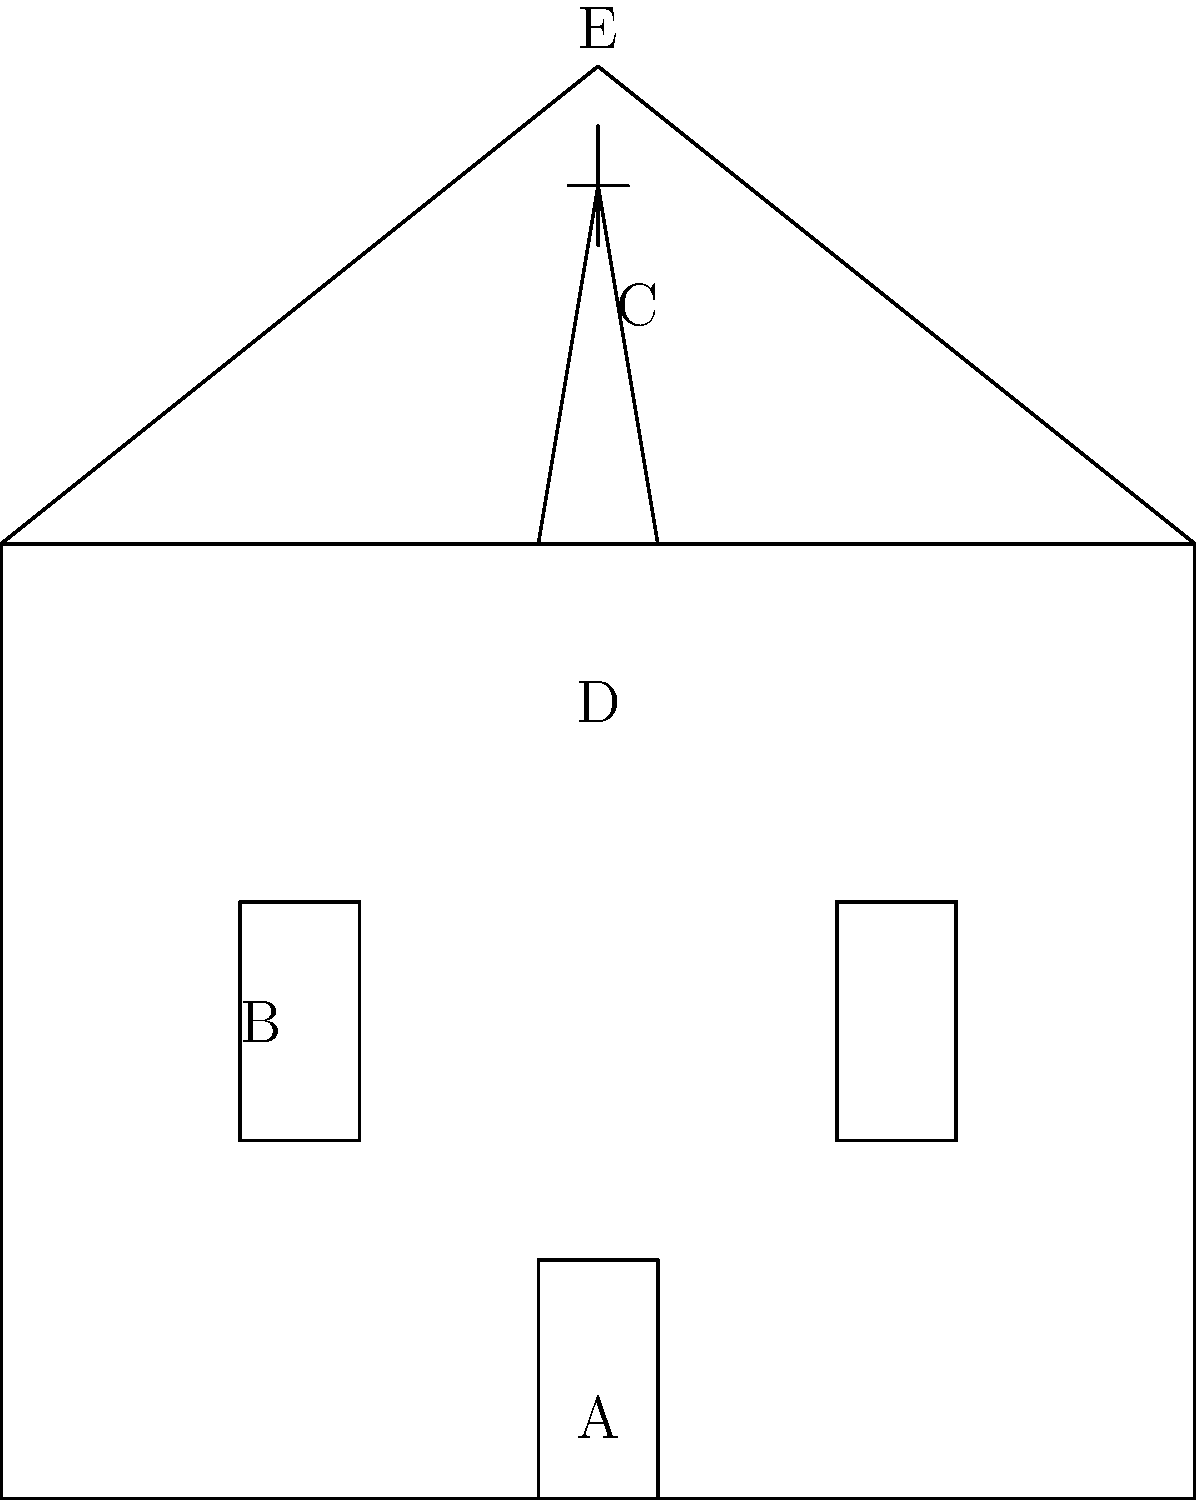In the diagram of a typical church building, which component is labeled 'C' and what is its significance in Evangelical Christian worship? To answer this question, let's break down the components of the church building shown in the diagram:

1. The main structure of the church is represented by a rectangular shape.
2. Label 'A' points to the entrance or door of the church.
3. Label 'B' indicates one of the windows on the side of the church.
4. Label 'D' is placed inside the main body of the church, likely representing the sanctuary or worship area.
5. Label 'E' is at the peak of the roof.

Label 'C' is pointing to the steeple of the church, which is the tall, tower-like structure on top of the building. The steeple is often topped with a cross, as shown in the diagram.

The significance of the steeple in Evangelical Christian worship:

1. Symbolism: The steeple points upward, symbolizing the church's focus on God and heaven.
2. Visibility: It makes the church building easily identifiable from a distance.
3. Historical function: In the past, steeples often housed church bells used to call people to worship.
4. Cross placement: The cross at the top of the steeple serves as a reminder of Christ's sacrifice and the core of Christian faith.

For an Evangelical Christian, the steeple represents the church's mission to proclaim the Gospel and point people towards God. It's a visual representation of the church's role as a beacon of faith in the community.
Answer: Steeple 